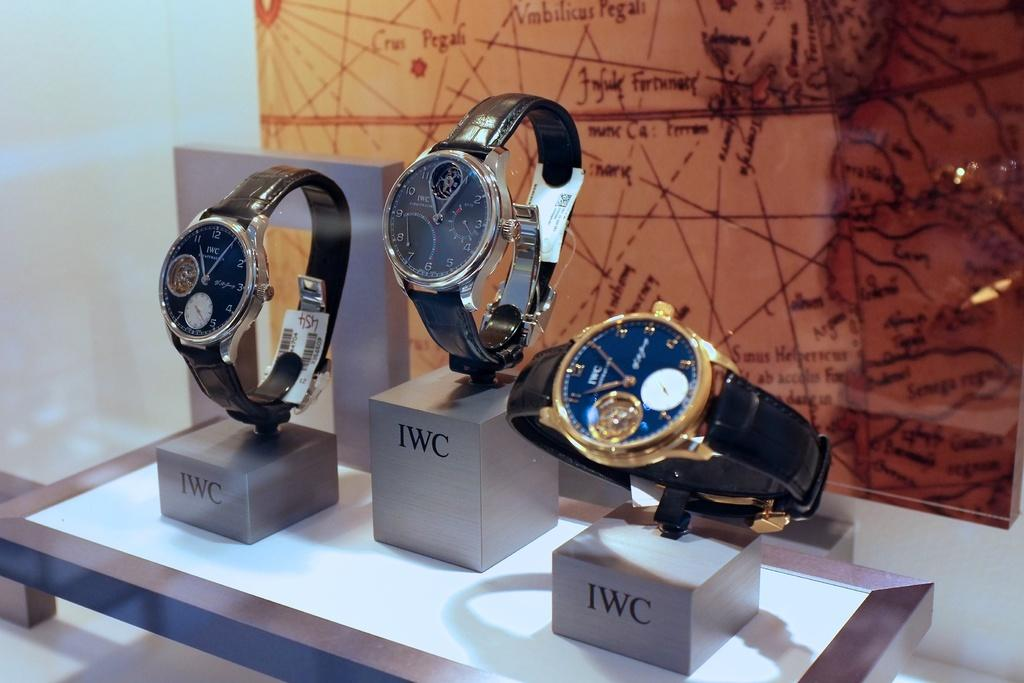<image>
Give a short and clear explanation of the subsequent image. Wrist watches being put on display on top of a sign that says IWC. 